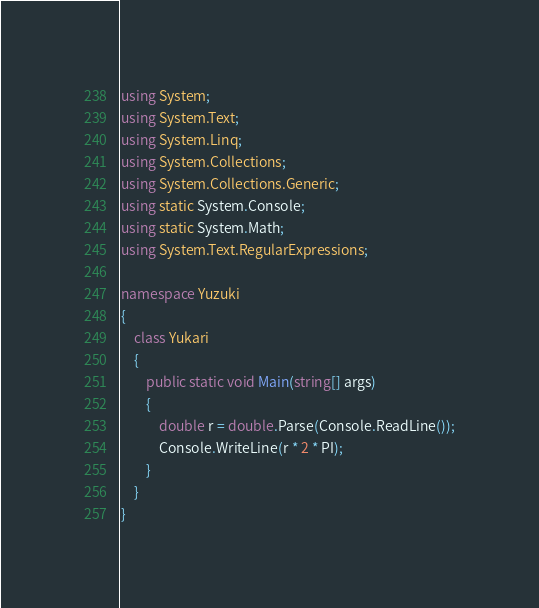Convert code to text. <code><loc_0><loc_0><loc_500><loc_500><_C#_>using System;
using System.Text;
using System.Linq;
using System.Collections;
using System.Collections.Generic;
using static System.Console;
using static System.Math;
using System.Text.RegularExpressions;

namespace Yuzuki
{
    class Yukari
    {
        public static void Main(string[] args)
        {
            double r = double.Parse(Console.ReadLine());
            Console.WriteLine(r * 2 * PI);
        }
    }
}</code> 